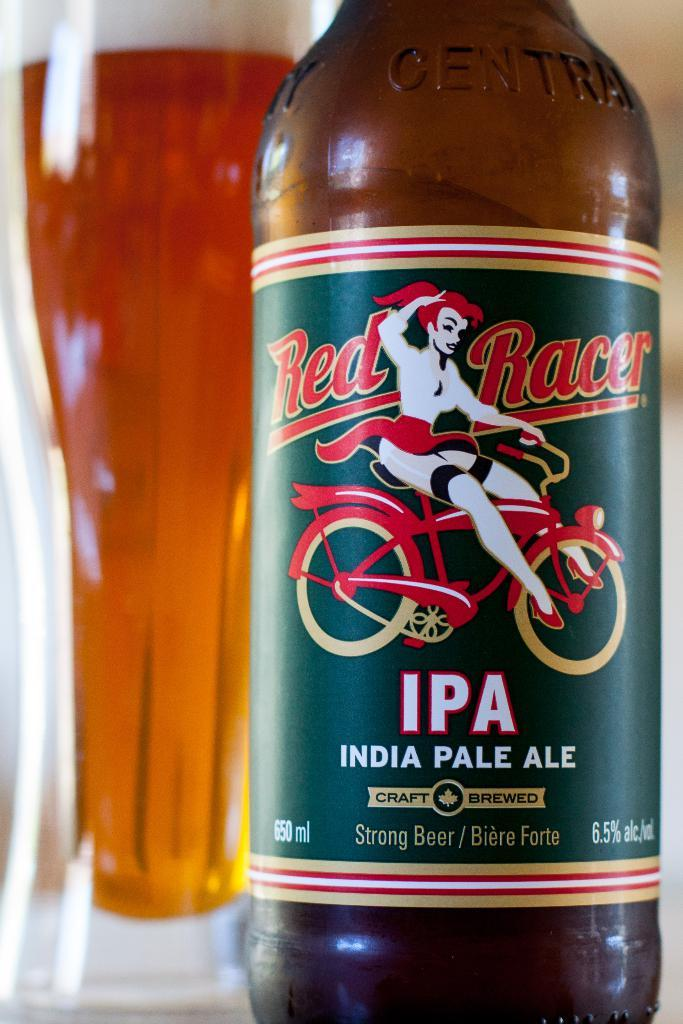<image>
Summarize the visual content of the image. Craft brewed and delicious, the red racer ale has been poured into a glass 